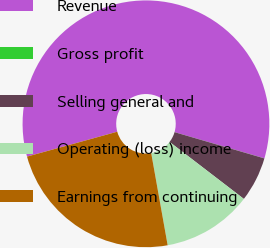Convert chart. <chart><loc_0><loc_0><loc_500><loc_500><pie_chart><fcel>Revenue<fcel>Gross profit<fcel>Selling general and<fcel>Operating (loss) income<fcel>Earnings from continuing<nl><fcel>58.8%<fcel>0.01%<fcel>5.89%<fcel>11.77%<fcel>23.53%<nl></chart> 